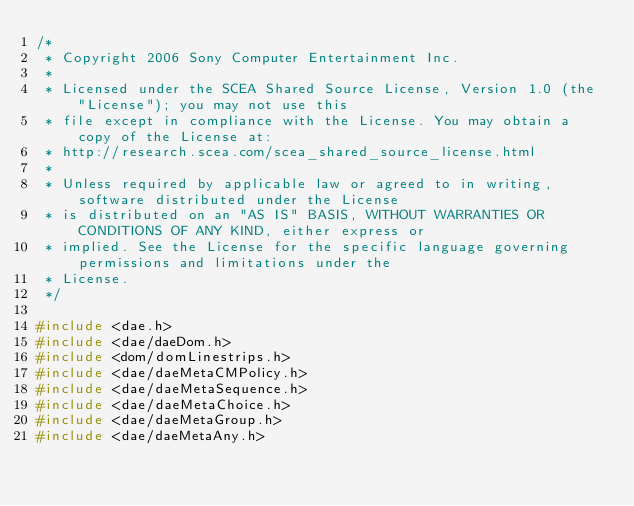<code> <loc_0><loc_0><loc_500><loc_500><_C++_>/*
 * Copyright 2006 Sony Computer Entertainment Inc.
 *
 * Licensed under the SCEA Shared Source License, Version 1.0 (the "License"); you may not use this
 * file except in compliance with the License. You may obtain a copy of the License at:
 * http://research.scea.com/scea_shared_source_license.html
 *
 * Unless required by applicable law or agreed to in writing, software distributed under the License
 * is distributed on an "AS IS" BASIS, WITHOUT WARRANTIES OR CONDITIONS OF ANY KIND, either express or
 * implied. See the License for the specific language governing permissions and limitations under the
 * License.
 */

#include <dae.h>
#include <dae/daeDom.h>
#include <dom/domLinestrips.h>
#include <dae/daeMetaCMPolicy.h>
#include <dae/daeMetaSequence.h>
#include <dae/daeMetaChoice.h>
#include <dae/daeMetaGroup.h>
#include <dae/daeMetaAny.h></code> 